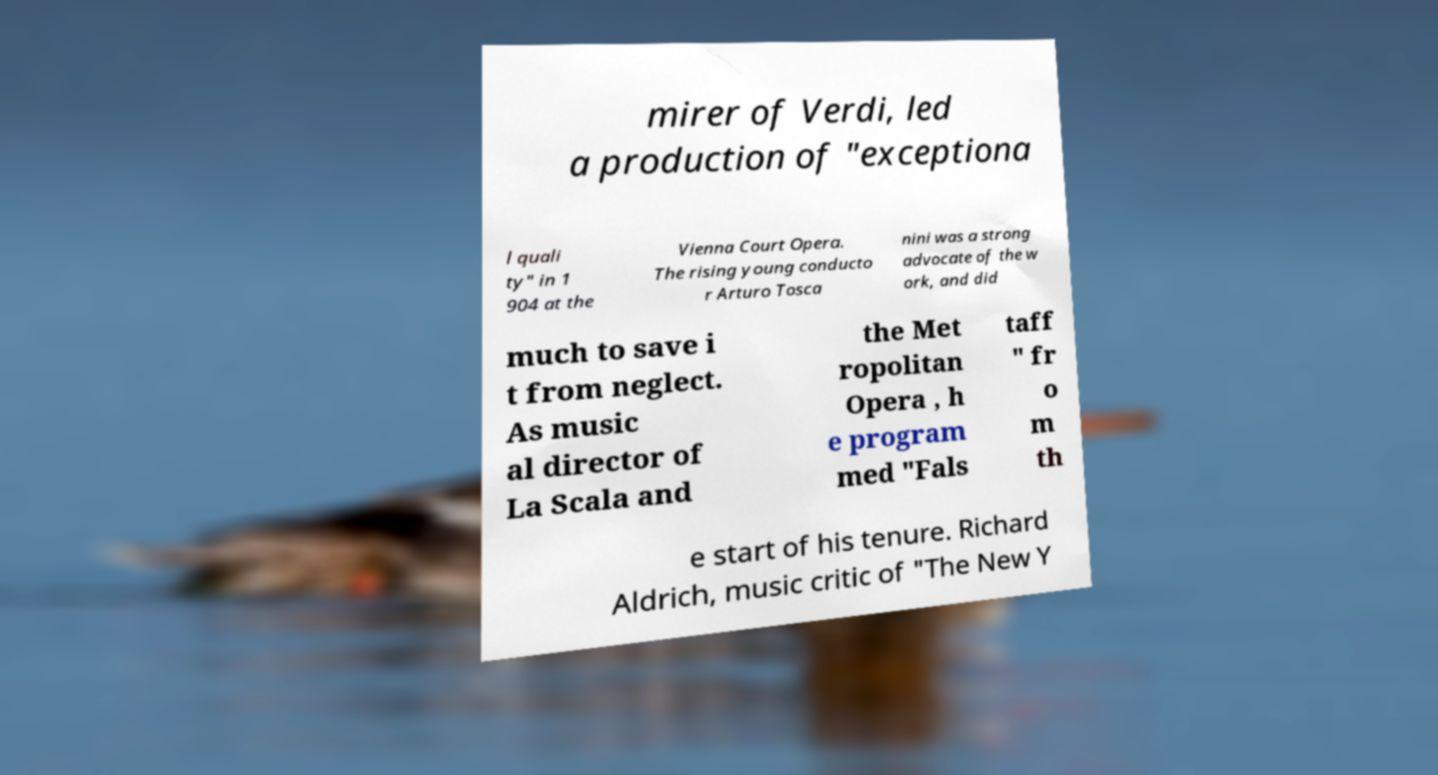Could you extract and type out the text from this image? mirer of Verdi, led a production of "exceptiona l quali ty" in 1 904 at the Vienna Court Opera. The rising young conducto r Arturo Tosca nini was a strong advocate of the w ork, and did much to save i t from neglect. As music al director of La Scala and the Met ropolitan Opera , h e program med "Fals taff " fr o m th e start of his tenure. Richard Aldrich, music critic of "The New Y 